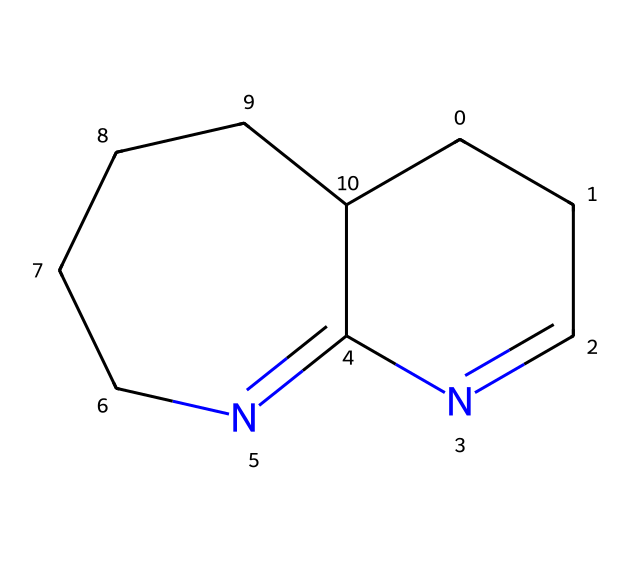What is the molecular formula of DBU? The SMILES code represents the structure of 1,8-diazabicyclo[5.4.0]undec-7-ene. To derive its molecular formula, we identify the number of each type of atom present in the structure. It contains 11 carbon atoms, 14 hydrogen atoms, and 2 nitrogen atoms, leading to the molecular formula C11H14N2.
Answer: C11H14N2 How many rings are present in the structure of DBU? The SMILES notation reflects a bicyclic structure, which indicates the presence of two interconnected rings. Specifically, it denotes a bicyclo[5.4.0] framework, confirming that there are 2 rings in total.
Answer: 2 What type of base is DBU classified as? DBU is recognized as a superbase due to its high basicity. This classification comes from its ability to deprotonate a wide variety of compounds, making it particularly effective for various chemical reactions.
Answer: superbase What is the main functional group in DBU? The prominent feature in the structure of DBU is the nitrogen atoms which contribute to its basic properties. Their presence indicates that DBU has amine functional characteristics, essential for its behavior in reactions.
Answer: amine What is the pKa value of DBU? DBU is known to have a significantly high pKa value, indicative of its high basicity. Specifically, the pKa for DBU is around 12.5, showing it is a strong base even compared to conventional amines.
Answer: 12.5 How does the bicyclic structure of DBU affect its basicity? The bicyclic arrangement in DBU provides stability to the nitrogen atoms, which can hold on to the extra electron pair more effectively. This structural configuration can significantly contribute to enhancing the molecule's basicity.
Answer: stability of nitrogen 